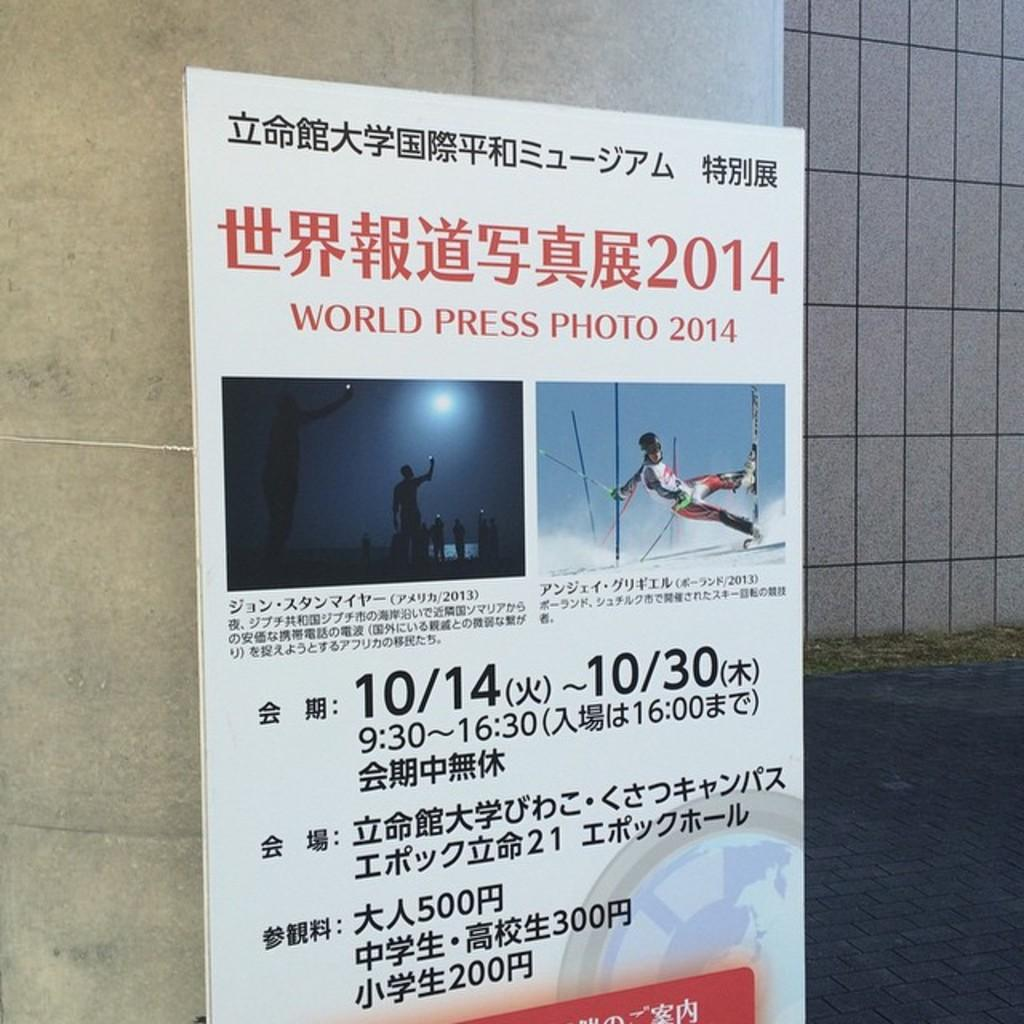<image>
Offer a succinct explanation of the picture presented. A large poster that reads world press photo 2014 with two pictures. 